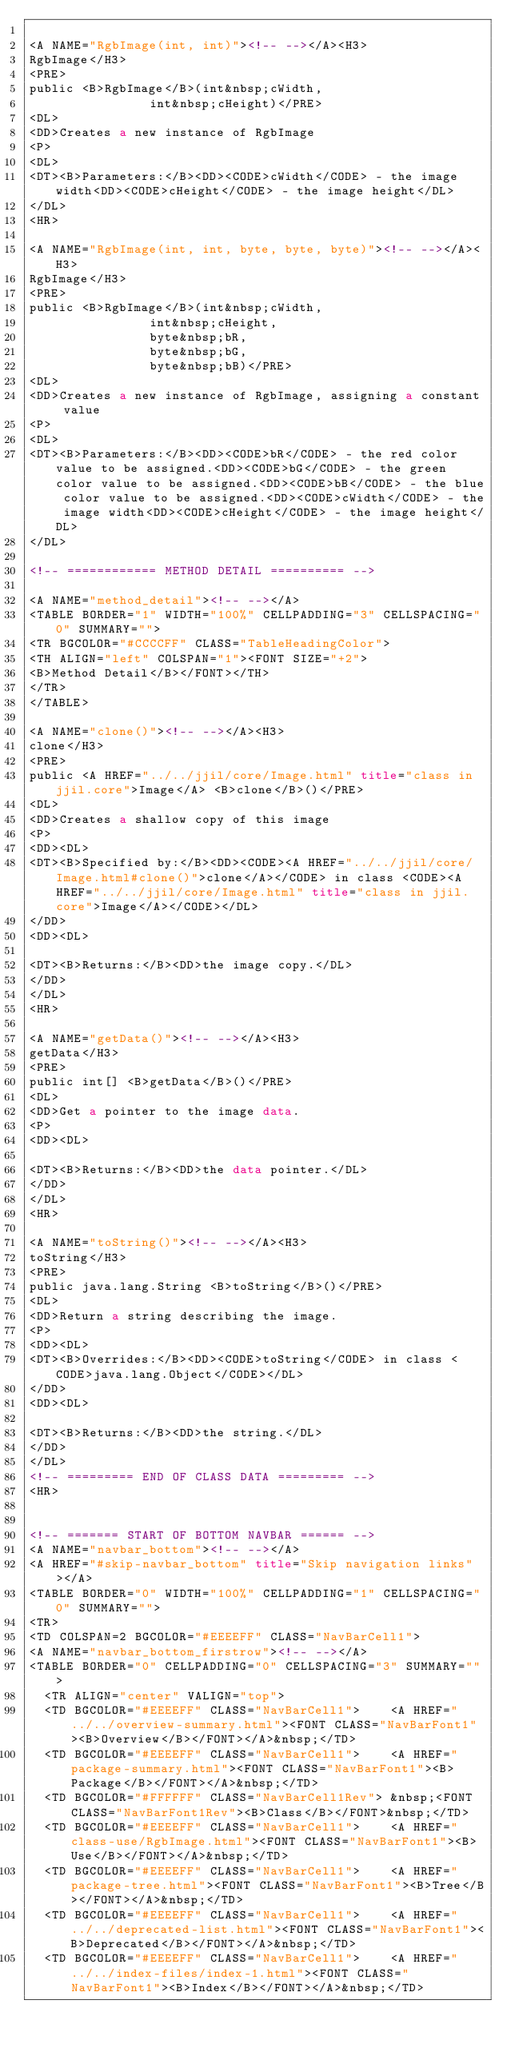Convert code to text. <code><loc_0><loc_0><loc_500><loc_500><_HTML_>
<A NAME="RgbImage(int, int)"><!-- --></A><H3>
RgbImage</H3>
<PRE>
public <B>RgbImage</B>(int&nbsp;cWidth,
                int&nbsp;cHeight)</PRE>
<DL>
<DD>Creates a new instance of RgbImage
<P>
<DL>
<DT><B>Parameters:</B><DD><CODE>cWidth</CODE> - the image width<DD><CODE>cHeight</CODE> - the image height</DL>
</DL>
<HR>

<A NAME="RgbImage(int, int, byte, byte, byte)"><!-- --></A><H3>
RgbImage</H3>
<PRE>
public <B>RgbImage</B>(int&nbsp;cWidth,
                int&nbsp;cHeight,
                byte&nbsp;bR,
                byte&nbsp;bG,
                byte&nbsp;bB)</PRE>
<DL>
<DD>Creates a new instance of RgbImage, assigning a constant value
<P>
<DL>
<DT><B>Parameters:</B><DD><CODE>bR</CODE> - the red color value to be assigned.<DD><CODE>bG</CODE> - the green color value to be assigned.<DD><CODE>bB</CODE> - the blue color value to be assigned.<DD><CODE>cWidth</CODE> - the image width<DD><CODE>cHeight</CODE> - the image height</DL>
</DL>

<!-- ============ METHOD DETAIL ========== -->

<A NAME="method_detail"><!-- --></A>
<TABLE BORDER="1" WIDTH="100%" CELLPADDING="3" CELLSPACING="0" SUMMARY="">
<TR BGCOLOR="#CCCCFF" CLASS="TableHeadingColor">
<TH ALIGN="left" COLSPAN="1"><FONT SIZE="+2">
<B>Method Detail</B></FONT></TH>
</TR>
</TABLE>

<A NAME="clone()"><!-- --></A><H3>
clone</H3>
<PRE>
public <A HREF="../../jjil/core/Image.html" title="class in jjil.core">Image</A> <B>clone</B>()</PRE>
<DL>
<DD>Creates a shallow copy of this image
<P>
<DD><DL>
<DT><B>Specified by:</B><DD><CODE><A HREF="../../jjil/core/Image.html#clone()">clone</A></CODE> in class <CODE><A HREF="../../jjil/core/Image.html" title="class in jjil.core">Image</A></CODE></DL>
</DD>
<DD><DL>

<DT><B>Returns:</B><DD>the image copy.</DL>
</DD>
</DL>
<HR>

<A NAME="getData()"><!-- --></A><H3>
getData</H3>
<PRE>
public int[] <B>getData</B>()</PRE>
<DL>
<DD>Get a pointer to the image data.
<P>
<DD><DL>

<DT><B>Returns:</B><DD>the data pointer.</DL>
</DD>
</DL>
<HR>

<A NAME="toString()"><!-- --></A><H3>
toString</H3>
<PRE>
public java.lang.String <B>toString</B>()</PRE>
<DL>
<DD>Return a string describing the image.
<P>
<DD><DL>
<DT><B>Overrides:</B><DD><CODE>toString</CODE> in class <CODE>java.lang.Object</CODE></DL>
</DD>
<DD><DL>

<DT><B>Returns:</B><DD>the string.</DL>
</DD>
</DL>
<!-- ========= END OF CLASS DATA ========= -->
<HR>


<!-- ======= START OF BOTTOM NAVBAR ====== -->
<A NAME="navbar_bottom"><!-- --></A>
<A HREF="#skip-navbar_bottom" title="Skip navigation links"></A>
<TABLE BORDER="0" WIDTH="100%" CELLPADDING="1" CELLSPACING="0" SUMMARY="">
<TR>
<TD COLSPAN=2 BGCOLOR="#EEEEFF" CLASS="NavBarCell1">
<A NAME="navbar_bottom_firstrow"><!-- --></A>
<TABLE BORDER="0" CELLPADDING="0" CELLSPACING="3" SUMMARY="">
  <TR ALIGN="center" VALIGN="top">
  <TD BGCOLOR="#EEEEFF" CLASS="NavBarCell1">    <A HREF="../../overview-summary.html"><FONT CLASS="NavBarFont1"><B>Overview</B></FONT></A>&nbsp;</TD>
  <TD BGCOLOR="#EEEEFF" CLASS="NavBarCell1">    <A HREF="package-summary.html"><FONT CLASS="NavBarFont1"><B>Package</B></FONT></A>&nbsp;</TD>
  <TD BGCOLOR="#FFFFFF" CLASS="NavBarCell1Rev"> &nbsp;<FONT CLASS="NavBarFont1Rev"><B>Class</B></FONT>&nbsp;</TD>
  <TD BGCOLOR="#EEEEFF" CLASS="NavBarCell1">    <A HREF="class-use/RgbImage.html"><FONT CLASS="NavBarFont1"><B>Use</B></FONT></A>&nbsp;</TD>
  <TD BGCOLOR="#EEEEFF" CLASS="NavBarCell1">    <A HREF="package-tree.html"><FONT CLASS="NavBarFont1"><B>Tree</B></FONT></A>&nbsp;</TD>
  <TD BGCOLOR="#EEEEFF" CLASS="NavBarCell1">    <A HREF="../../deprecated-list.html"><FONT CLASS="NavBarFont1"><B>Deprecated</B></FONT></A>&nbsp;</TD>
  <TD BGCOLOR="#EEEEFF" CLASS="NavBarCell1">    <A HREF="../../index-files/index-1.html"><FONT CLASS="NavBarFont1"><B>Index</B></FONT></A>&nbsp;</TD></code> 